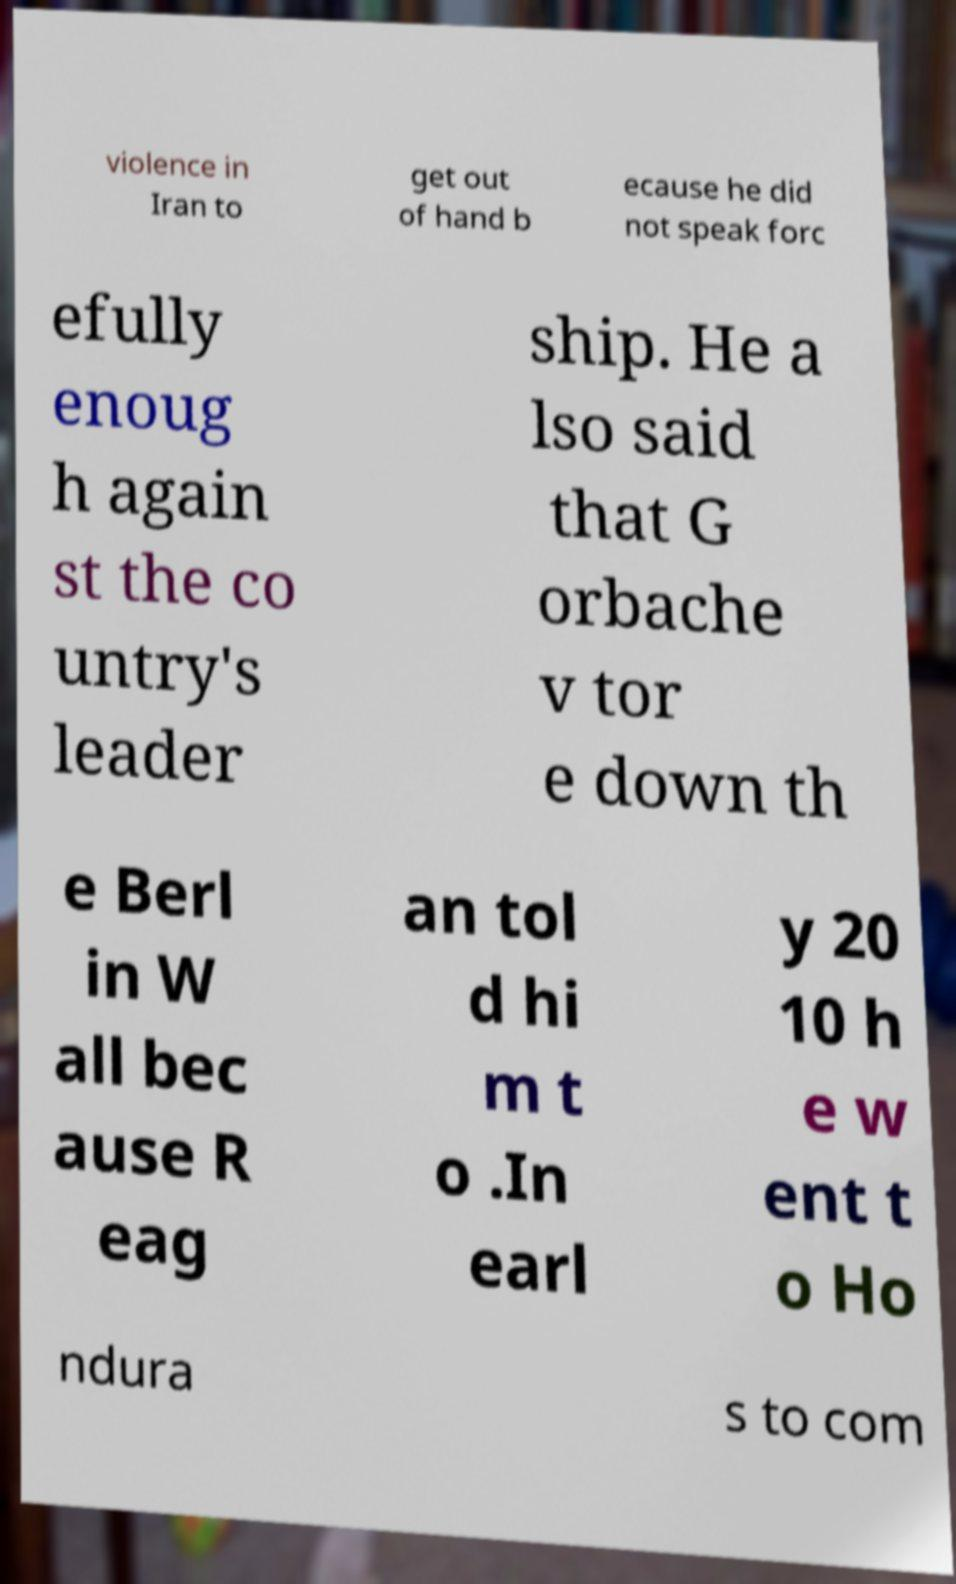What messages or text are displayed in this image? I need them in a readable, typed format. violence in Iran to get out of hand b ecause he did not speak forc efully enoug h again st the co untry's leader ship. He a lso said that G orbache v tor e down th e Berl in W all bec ause R eag an tol d hi m t o .In earl y 20 10 h e w ent t o Ho ndura s to com 